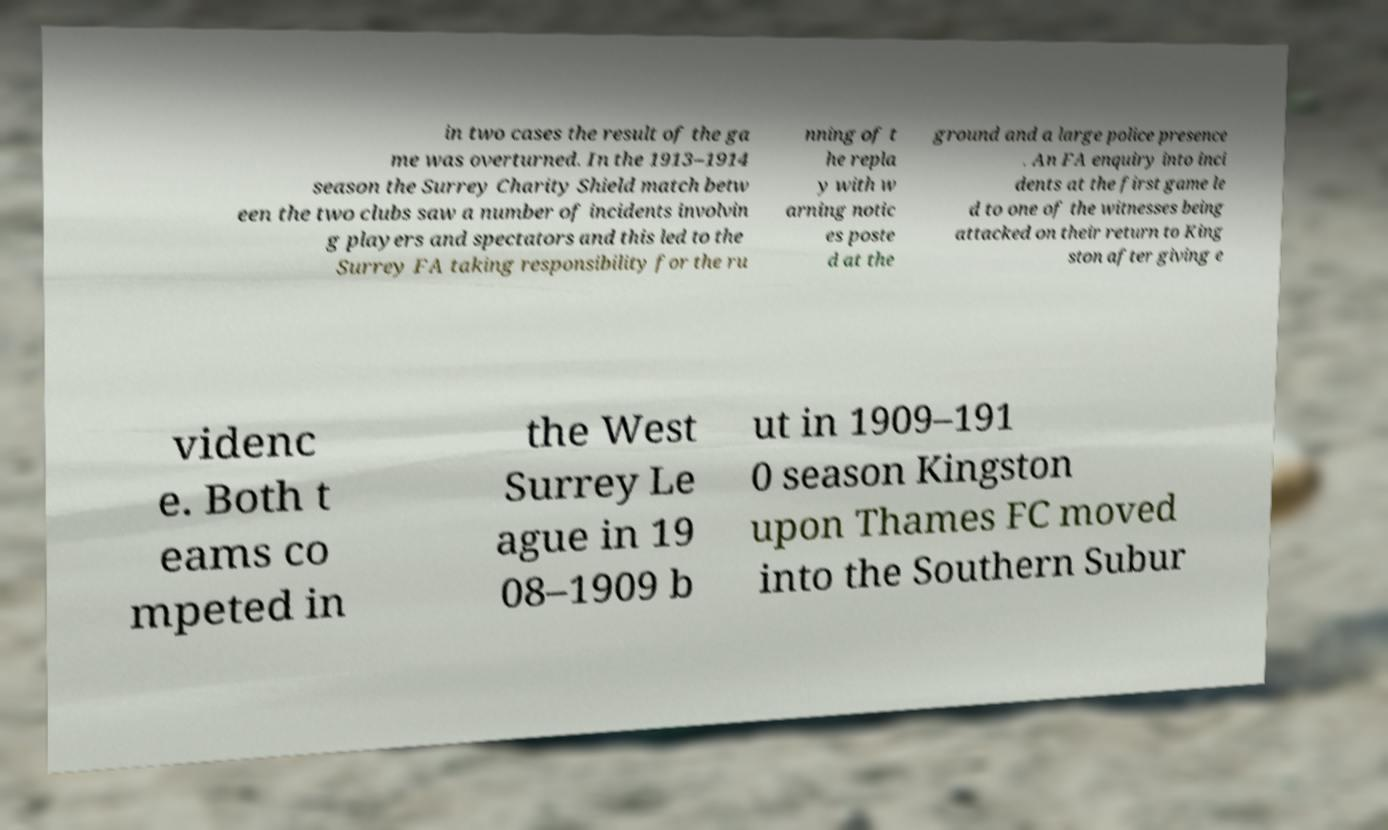Can you accurately transcribe the text from the provided image for me? in two cases the result of the ga me was overturned. In the 1913–1914 season the Surrey Charity Shield match betw een the two clubs saw a number of incidents involvin g players and spectators and this led to the Surrey FA taking responsibility for the ru nning of t he repla y with w arning notic es poste d at the ground and a large police presence . An FA enquiry into inci dents at the first game le d to one of the witnesses being attacked on their return to King ston after giving e videnc e. Both t eams co mpeted in the West Surrey Le ague in 19 08–1909 b ut in 1909–191 0 season Kingston upon Thames FC moved into the Southern Subur 